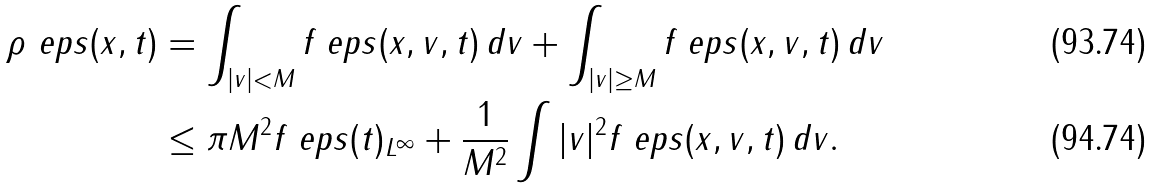<formula> <loc_0><loc_0><loc_500><loc_500>\rho _ { \ } e p s ( x , t ) & = \int _ { | v | < M } f _ { \ } e p s ( x , v , t ) \, d v + \int _ { | v | \geq M } f _ { \ } e p s ( x , v , t ) \, d v \\ & \leq \pi M ^ { 2 } \| f _ { \ } e p s ( t ) \| _ { L ^ { \infty } } + \frac { 1 } { M ^ { 2 } } \int | v | ^ { 2 } f _ { \ } e p s ( x , v , t ) \, d v .</formula> 